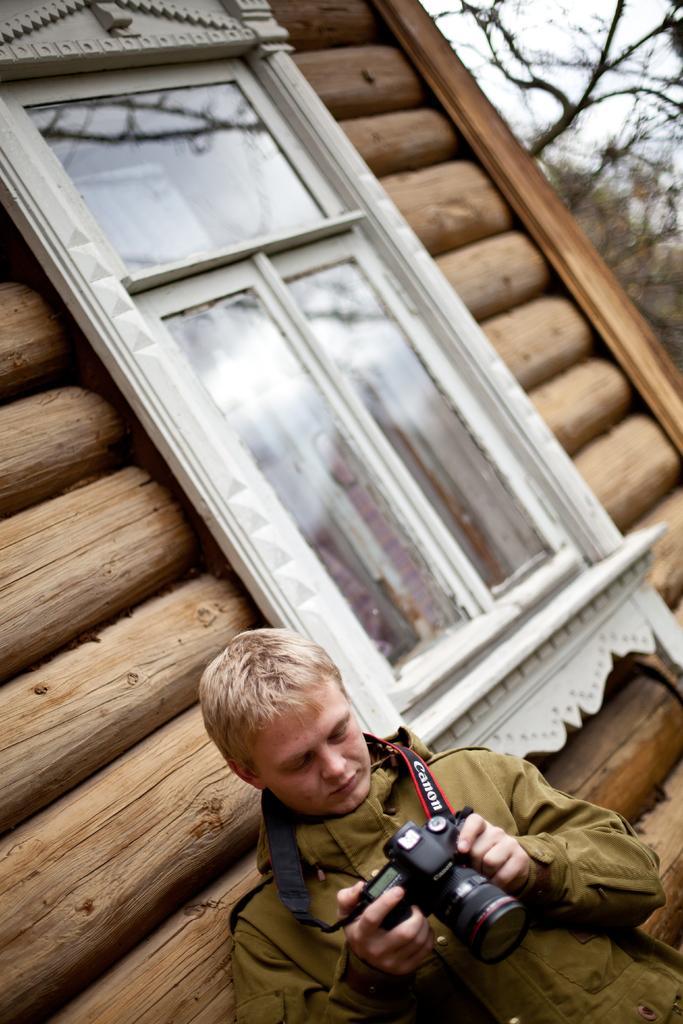In one or two sentences, can you explain what this image depicts? This is an outside view. There is a person wearing shirt and holding a camera in his hands and looking at the camera. Just beside the person there is a wooden wall. On the top right of the Image can see the trees. 